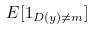<formula> <loc_0><loc_0><loc_500><loc_500>E [ 1 _ { D ( y ) \ne m } ]</formula> 